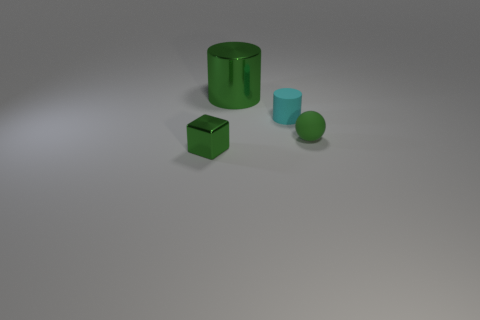Do the object behind the matte cylinder and the small green rubber thing have the same shape?
Your answer should be compact. No. What number of things are tiny blocks or metallic cylinders?
Your response must be concise. 2. Do the small green object that is to the left of the green matte object and the cyan thing have the same material?
Your response must be concise. No. How big is the metallic cylinder?
Make the answer very short. Large. There is a big object that is the same color as the tiny cube; what shape is it?
Give a very brief answer. Cylinder. What number of spheres are cyan objects or red things?
Keep it short and to the point. 0. Are there the same number of green balls behind the cyan rubber thing and green cubes on the left side of the big metal thing?
Your response must be concise. No. The metallic object that is the same shape as the cyan rubber object is what size?
Your response must be concise. Large. How big is the green thing that is in front of the tiny cyan rubber thing and on the left side of the tiny sphere?
Provide a short and direct response. Small. Are there any rubber balls in front of the small green metallic object?
Ensure brevity in your answer.  No. 